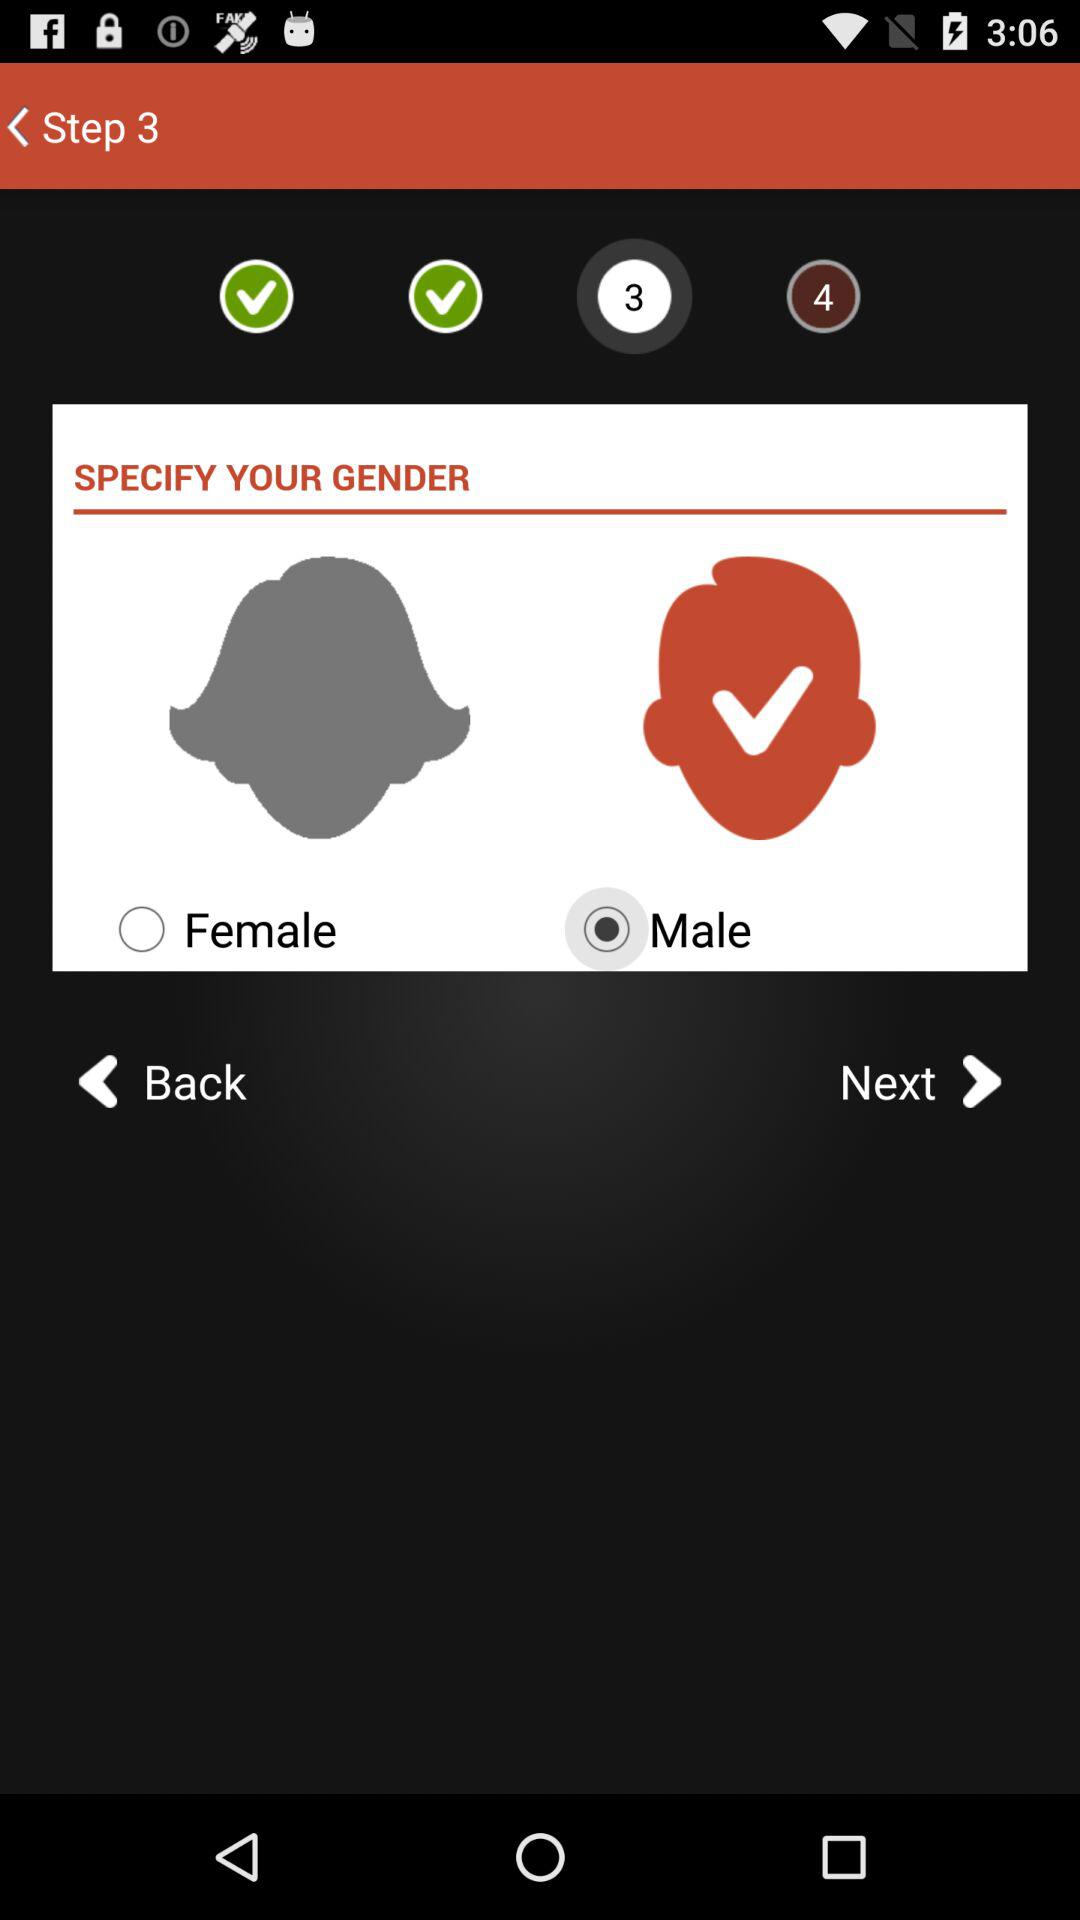At which step am I? You are at step 3. 